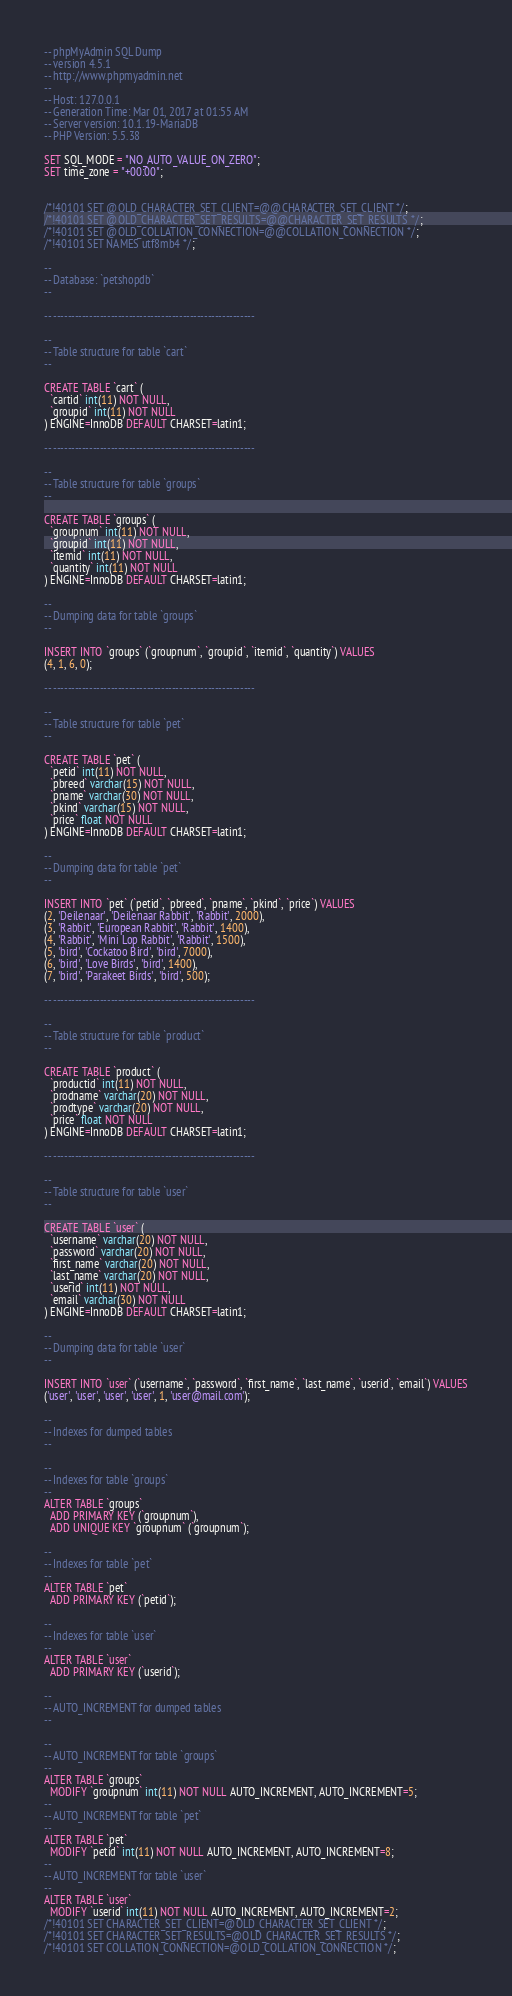Convert code to text. <code><loc_0><loc_0><loc_500><loc_500><_SQL_>-- phpMyAdmin SQL Dump
-- version 4.5.1
-- http://www.phpmyadmin.net
--
-- Host: 127.0.0.1
-- Generation Time: Mar 01, 2017 at 01:55 AM
-- Server version: 10.1.19-MariaDB
-- PHP Version: 5.5.38

SET SQL_MODE = "NO_AUTO_VALUE_ON_ZERO";
SET time_zone = "+00:00";


/*!40101 SET @OLD_CHARACTER_SET_CLIENT=@@CHARACTER_SET_CLIENT */;
/*!40101 SET @OLD_CHARACTER_SET_RESULTS=@@CHARACTER_SET_RESULTS */;
/*!40101 SET @OLD_COLLATION_CONNECTION=@@COLLATION_CONNECTION */;
/*!40101 SET NAMES utf8mb4 */;

--
-- Database: `petshopdb`
--

-- --------------------------------------------------------

--
-- Table structure for table `cart`
--

CREATE TABLE `cart` (
  `cartid` int(11) NOT NULL,
  `groupid` int(11) NOT NULL
) ENGINE=InnoDB DEFAULT CHARSET=latin1;

-- --------------------------------------------------------

--
-- Table structure for table `groups`
--

CREATE TABLE `groups` (
  `groupnum` int(11) NOT NULL,
  `groupid` int(11) NOT NULL,
  `itemid` int(11) NOT NULL,
  `quantity` int(11) NOT NULL
) ENGINE=InnoDB DEFAULT CHARSET=latin1;

--
-- Dumping data for table `groups`
--

INSERT INTO `groups` (`groupnum`, `groupid`, `itemid`, `quantity`) VALUES
(4, 1, 6, 0);

-- --------------------------------------------------------

--
-- Table structure for table `pet`
--

CREATE TABLE `pet` (
  `petid` int(11) NOT NULL,
  `pbreed` varchar(15) NOT NULL,
  `pname` varchar(30) NOT NULL,
  `pkind` varchar(15) NOT NULL,
  `price` float NOT NULL
) ENGINE=InnoDB DEFAULT CHARSET=latin1;

--
-- Dumping data for table `pet`
--

INSERT INTO `pet` (`petid`, `pbreed`, `pname`, `pkind`, `price`) VALUES
(2, 'Deilenaar', 'Deilenaar Rabbit', 'Rabbit', 2000),
(3, 'Rabbit', 'European Rabbit', 'Rabbit', 1400),
(4, 'Rabbit', 'Mini Lop Rabbit', 'Rabbit', 1500),
(5, 'bird', 'Cockatoo Bird', 'bird', 7000),
(6, 'bird', 'Love Birds', 'bird', 1400),
(7, 'bird', 'Parakeet Birds', 'bird', 500);

-- --------------------------------------------------------

--
-- Table structure for table `product`
--

CREATE TABLE `product` (
  `productid` int(11) NOT NULL,
  `prodname` varchar(20) NOT NULL,
  `prodtype` varchar(20) NOT NULL,
  `price` float NOT NULL
) ENGINE=InnoDB DEFAULT CHARSET=latin1;

-- --------------------------------------------------------

--
-- Table structure for table `user`
--

CREATE TABLE `user` (
  `username` varchar(20) NOT NULL,
  `password` varchar(20) NOT NULL,
  `first_name` varchar(20) NOT NULL,
  `last_name` varchar(20) NOT NULL,
  `userid` int(11) NOT NULL,
  `email` varchar(30) NOT NULL
) ENGINE=InnoDB DEFAULT CHARSET=latin1;

--
-- Dumping data for table `user`
--

INSERT INTO `user` (`username`, `password`, `first_name`, `last_name`, `userid`, `email`) VALUES
('user', 'user', 'user', 'user', 1, 'user@mail.com');

--
-- Indexes for dumped tables
--

--
-- Indexes for table `groups`
--
ALTER TABLE `groups`
  ADD PRIMARY KEY (`groupnum`),
  ADD UNIQUE KEY `groupnum` (`groupnum`);

--
-- Indexes for table `pet`
--
ALTER TABLE `pet`
  ADD PRIMARY KEY (`petid`);

--
-- Indexes for table `user`
--
ALTER TABLE `user`
  ADD PRIMARY KEY (`userid`);

--
-- AUTO_INCREMENT for dumped tables
--

--
-- AUTO_INCREMENT for table `groups`
--
ALTER TABLE `groups`
  MODIFY `groupnum` int(11) NOT NULL AUTO_INCREMENT, AUTO_INCREMENT=5;
--
-- AUTO_INCREMENT for table `pet`
--
ALTER TABLE `pet`
  MODIFY `petid` int(11) NOT NULL AUTO_INCREMENT, AUTO_INCREMENT=8;
--
-- AUTO_INCREMENT for table `user`
--
ALTER TABLE `user`
  MODIFY `userid` int(11) NOT NULL AUTO_INCREMENT, AUTO_INCREMENT=2;
/*!40101 SET CHARACTER_SET_CLIENT=@OLD_CHARACTER_SET_CLIENT */;
/*!40101 SET CHARACTER_SET_RESULTS=@OLD_CHARACTER_SET_RESULTS */;
/*!40101 SET COLLATION_CONNECTION=@OLD_COLLATION_CONNECTION */;
</code> 